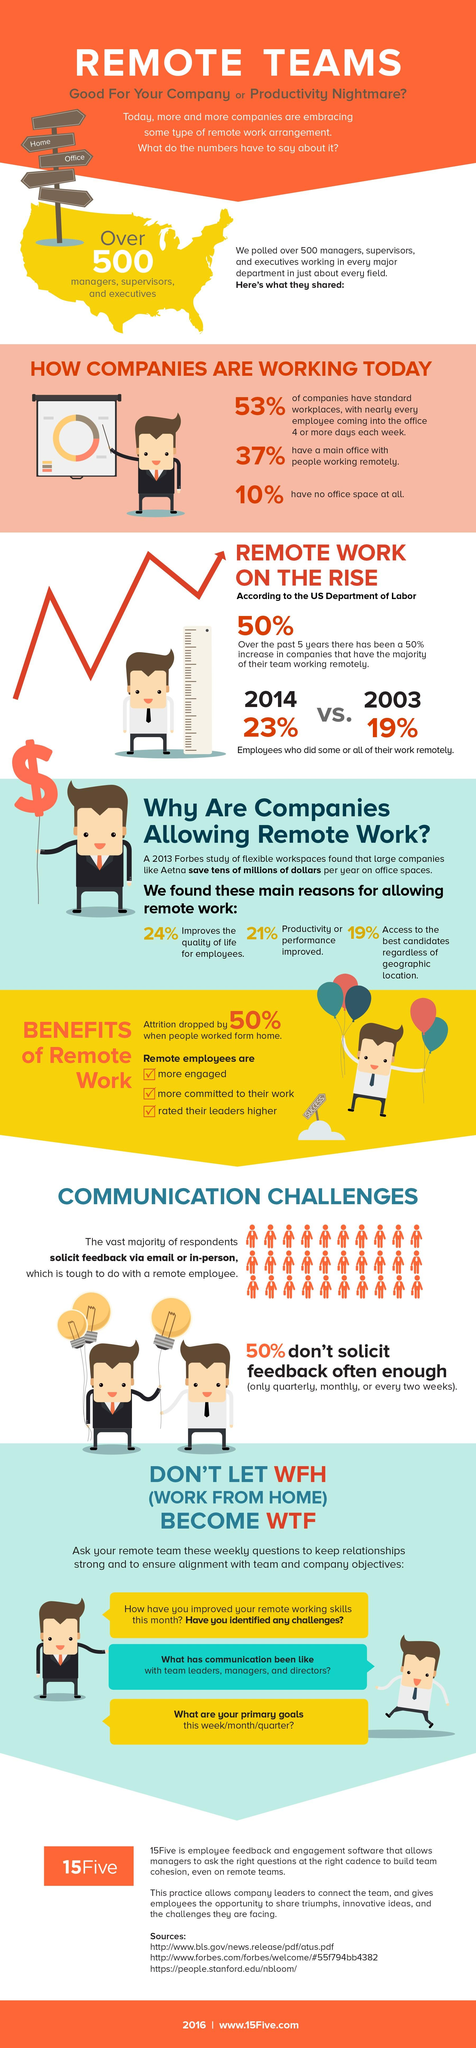Draw attention to some important aspects in this diagram. According to the US Department of Labor, in the year 2003, 19% of employees performed their work remotely. A study found that employees who work remotely experience a 21% increase in productivity and performance compared to those who work in an office setting. The quality of life for employees working remotely has increased by 24%. According to the US Department of Labor, in the year 2014, approximately 23% of employees worked remotely. 